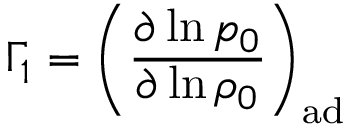<formula> <loc_0><loc_0><loc_500><loc_500>\Gamma _ { 1 } = \left ( \frac { \partial \ln p _ { 0 } } { \partial \ln \rho _ { 0 } } \right ) _ { a d }</formula> 